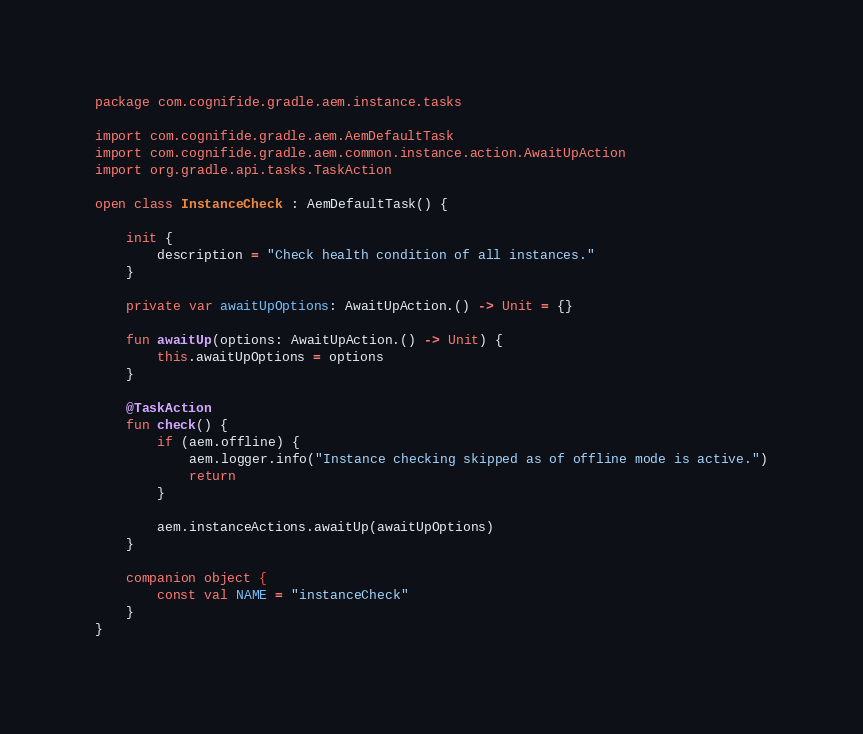Convert code to text. <code><loc_0><loc_0><loc_500><loc_500><_Kotlin_>package com.cognifide.gradle.aem.instance.tasks

import com.cognifide.gradle.aem.AemDefaultTask
import com.cognifide.gradle.aem.common.instance.action.AwaitUpAction
import org.gradle.api.tasks.TaskAction

open class InstanceCheck : AemDefaultTask() {

    init {
        description = "Check health condition of all instances."
    }

    private var awaitUpOptions: AwaitUpAction.() -> Unit = {}

    fun awaitUp(options: AwaitUpAction.() -> Unit) {
        this.awaitUpOptions = options
    }

    @TaskAction
    fun check() {
        if (aem.offline) {
            aem.logger.info("Instance checking skipped as of offline mode is active.")
            return
        }

        aem.instanceActions.awaitUp(awaitUpOptions)
    }

    companion object {
        const val NAME = "instanceCheck"
    }
}</code> 